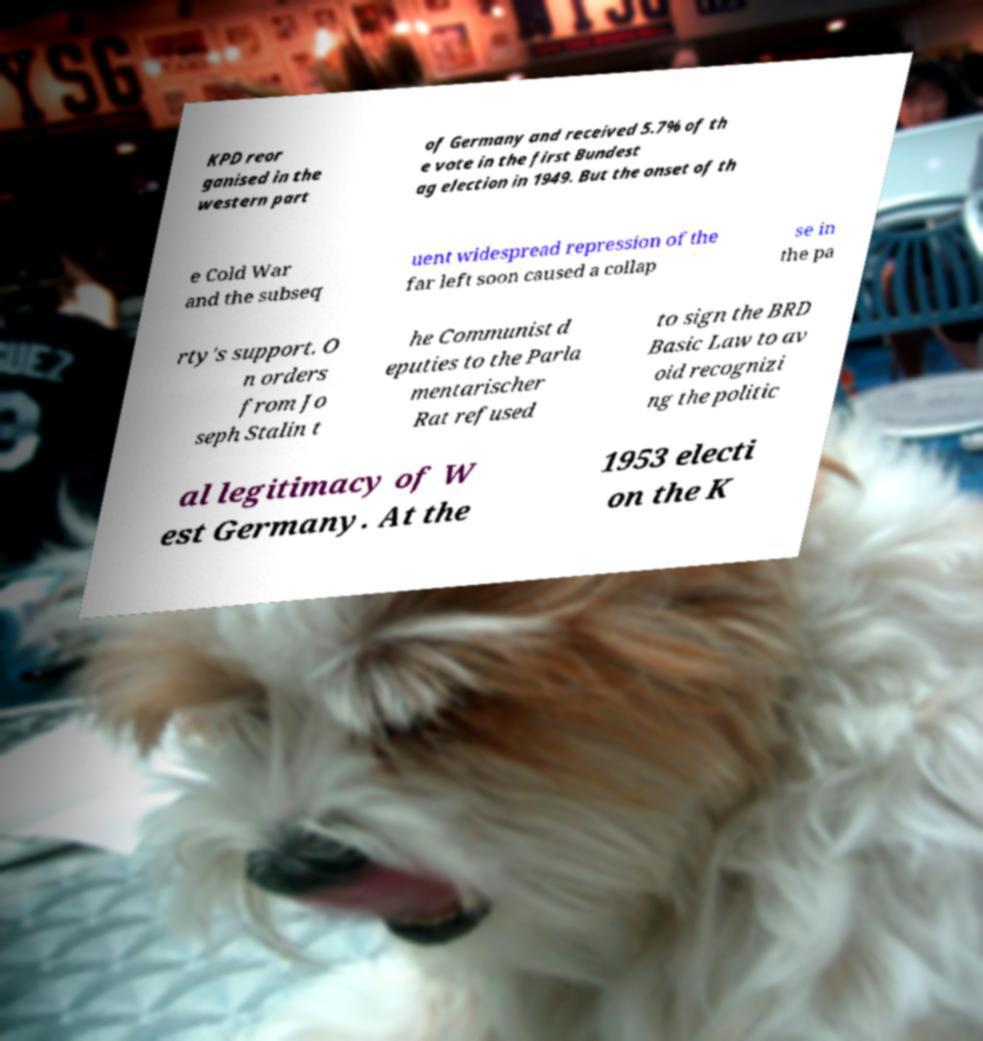What messages or text are displayed in this image? I need them in a readable, typed format. KPD reor ganised in the western part of Germany and received 5.7% of th e vote in the first Bundest ag election in 1949. But the onset of th e Cold War and the subseq uent widespread repression of the far left soon caused a collap se in the pa rty's support. O n orders from Jo seph Stalin t he Communist d eputies to the Parla mentarischer Rat refused to sign the BRD Basic Law to av oid recognizi ng the politic al legitimacy of W est Germany. At the 1953 electi on the K 